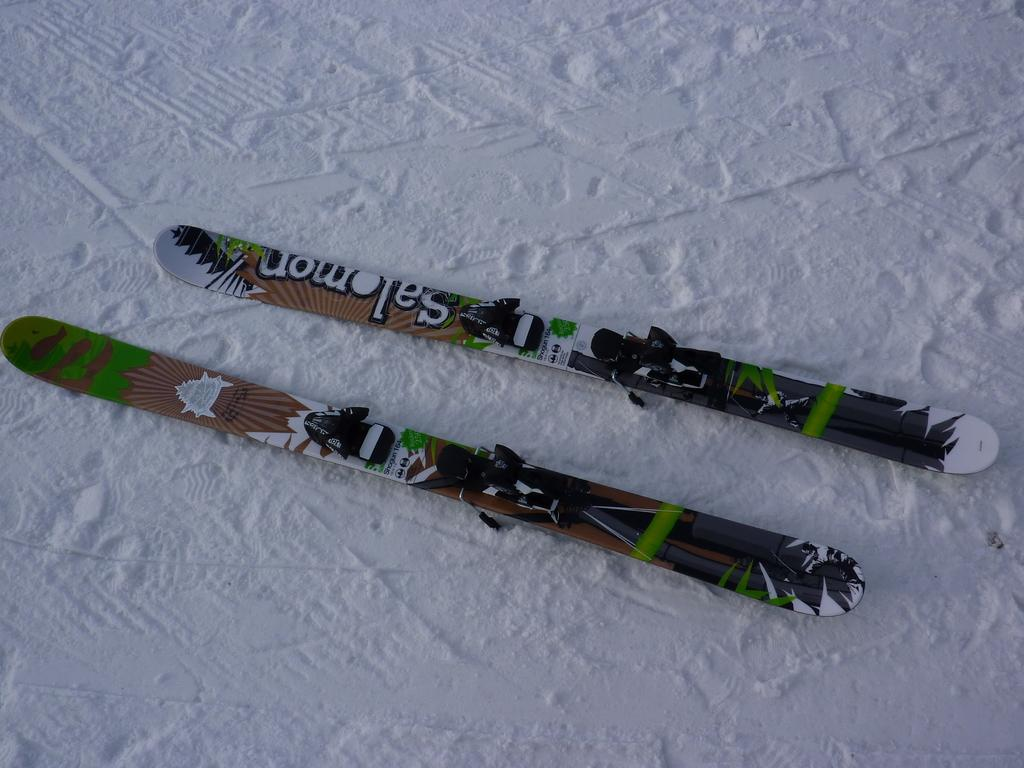What objects are present in the image related to skiing? There are two ski boards in the image. What colors can be seen on the ski boards? The ski boards are white, green, brown, and black in color. What is the surface on which the ski boards are placed? The ski boards are on white-colored snow. What type of bun can be seen on the ski boards in the image? There are no buns present on the ski boards in the image. 